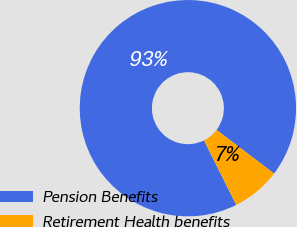Convert chart to OTSL. <chart><loc_0><loc_0><loc_500><loc_500><pie_chart><fcel>Pension Benefits<fcel>Retirement Health benefits<nl><fcel>92.71%<fcel>7.29%<nl></chart> 